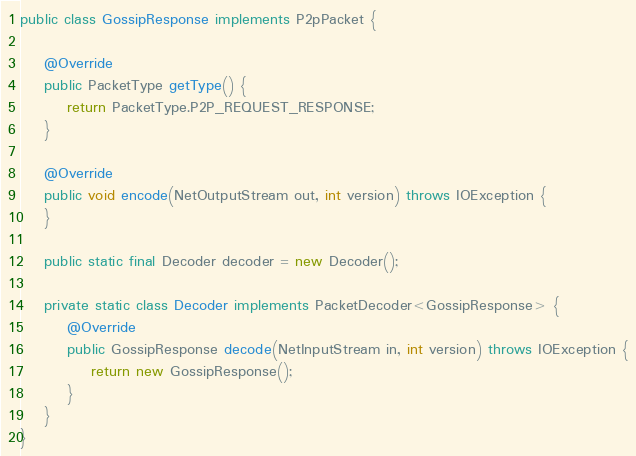Convert code to text. <code><loc_0><loc_0><loc_500><loc_500><_Java_>public class GossipResponse implements P2pPacket {

    @Override
    public PacketType getType() {
        return PacketType.P2P_REQUEST_RESPONSE;
    }

    @Override
    public void encode(NetOutputStream out, int version) throws IOException {
    }

    public static final Decoder decoder = new Decoder();

    private static class Decoder implements PacketDecoder<GossipResponse> {
        @Override
        public GossipResponse decode(NetInputStream in, int version) throws IOException {
            return new GossipResponse();
        }
    }
}
</code> 